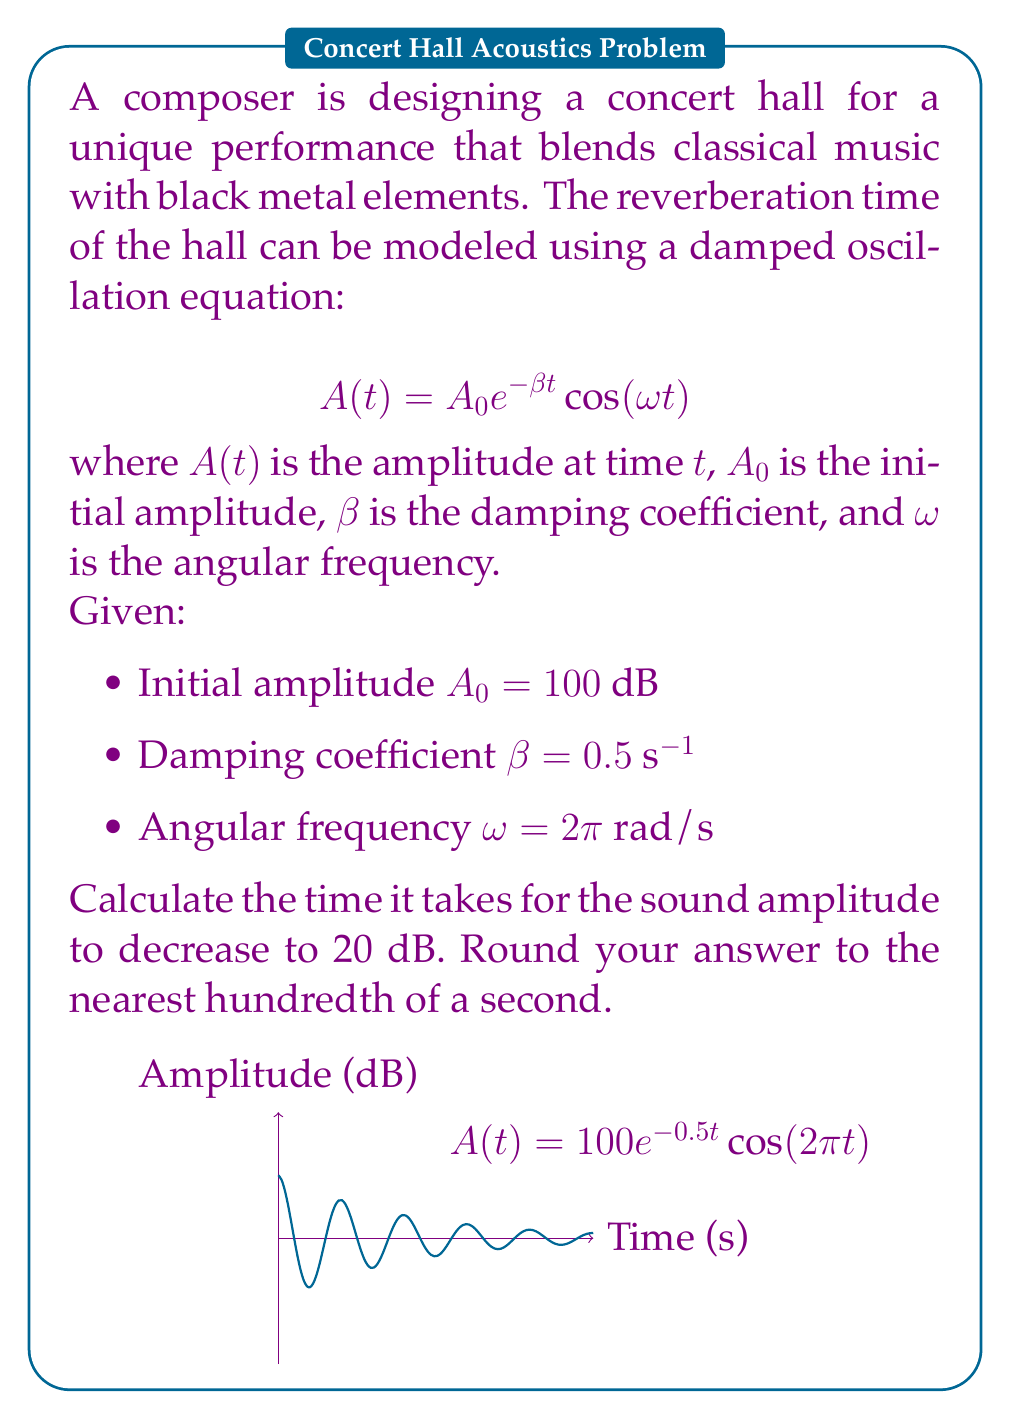Provide a solution to this math problem. Let's approach this step-by-step:

1) We need to find $t$ when $A(t) = 20$ dB. We can set up the equation:

   $$20 = 100 e^{-0.5t} \cos(2\pi t)$$

2) Isolate the cosine term:

   $$\frac{20}{100} = e^{-0.5t} \cos(2\pi t)$$
   $$0.2 = e^{-0.5t} \cos(2\pi t)$$

3) The cosine term oscillates between -1 and 1, so the maximum value of the right-hand side is when $\cos(2\pi t) = 1$. We can simplify:

   $$0.2 = e^{-0.5t}$$

4) Take the natural log of both sides:

   $$\ln(0.2) = -0.5t$$

5) Solve for $t$:

   $$t = -\frac{\ln(0.2)}{0.5} = -\frac{-1.60944}{0.5} = 3.21888$$

6) Rounding to the nearest hundredth:

   $$t \approx 3.22\text{ seconds}$$

This is the minimum time it takes for the amplitude to reach 20 dB. Due to the oscillatory nature of the function, it may take longer in reality, but this is the first instance it reaches this level.
Answer: 3.22 seconds 